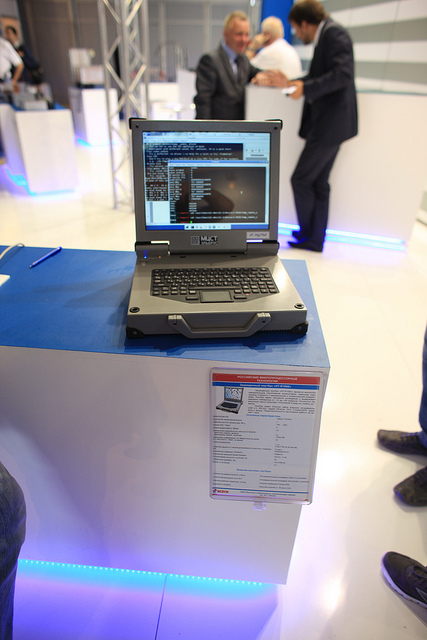Please transcribe the text in this image. MXT 